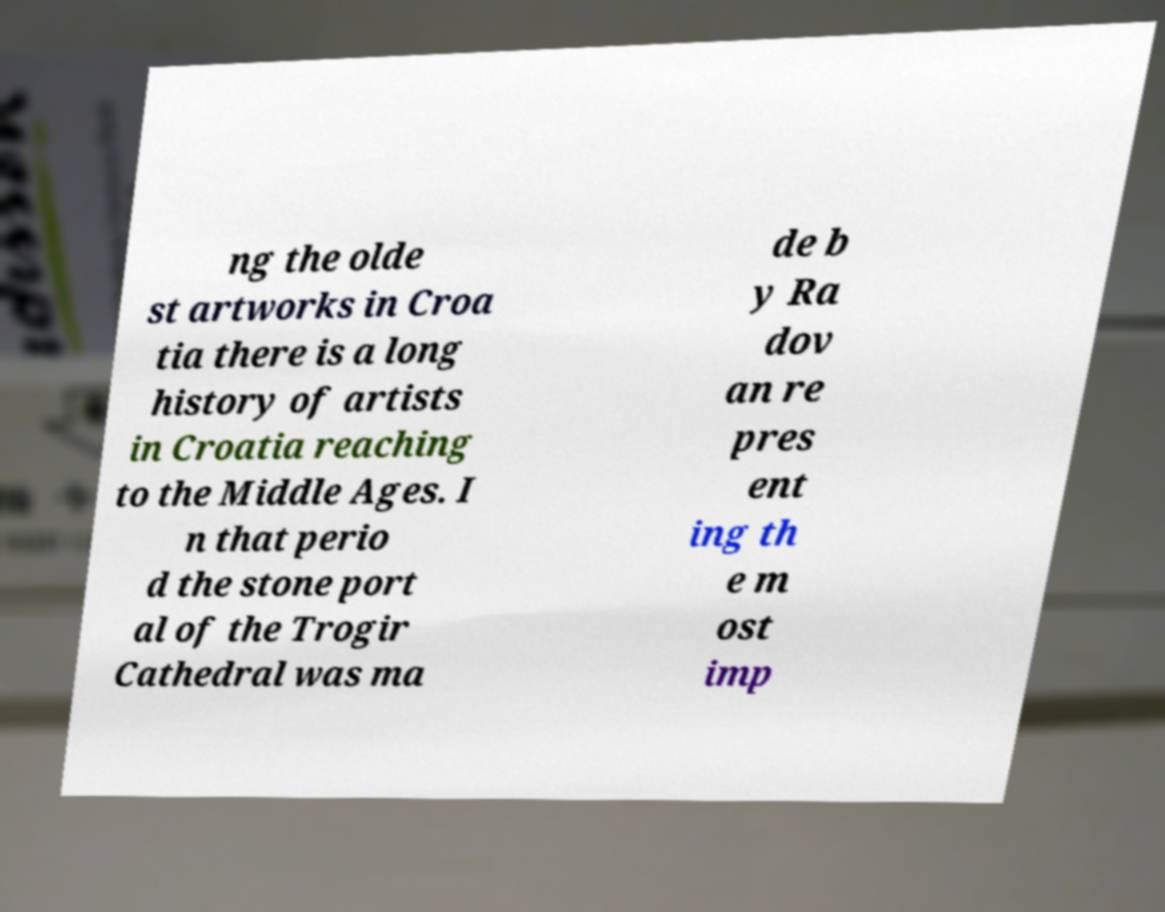I need the written content from this picture converted into text. Can you do that? ng the olde st artworks in Croa tia there is a long history of artists in Croatia reaching to the Middle Ages. I n that perio d the stone port al of the Trogir Cathedral was ma de b y Ra dov an re pres ent ing th e m ost imp 